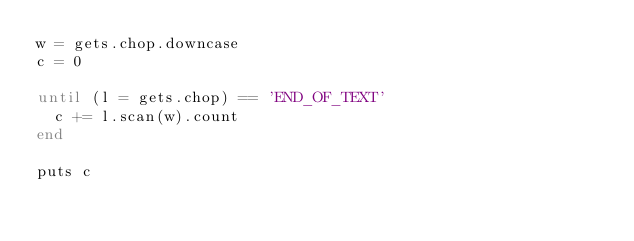<code> <loc_0><loc_0><loc_500><loc_500><_Ruby_>w = gets.chop.downcase
c = 0

until (l = gets.chop) == 'END_OF_TEXT'
  c += l.scan(w).count   
end

puts c</code> 